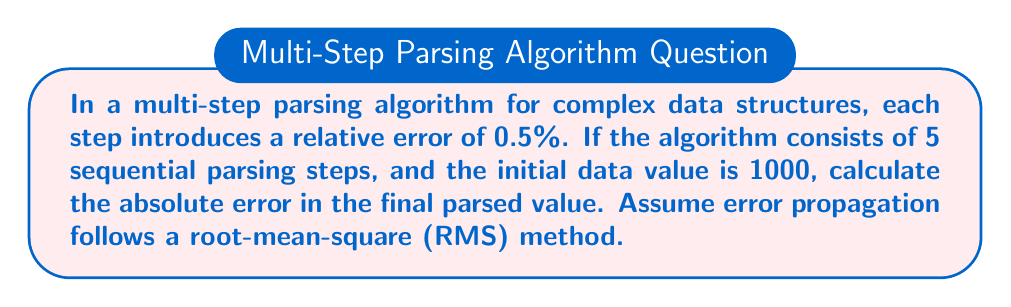Help me with this question. To solve this problem, we'll follow these steps:

1. Convert the relative error to decimal form:
   $$0.5\% = 0.005$$

2. Calculate the absolute error for each step:
   $$\text{Absolute Error per Step} = 1000 \times 0.005 = 5$$

3. Use the root-mean-square (RMS) method to calculate the total error:
   $$\text{Total Error} = \sqrt{\sum_{i=1}^{n} (\text{Error}_i)^2}$$
   Where n is the number of steps (5 in this case)

4. Substitute the values:
   $$\text{Total Error} = \sqrt{5^2 + 5^2 + 5^2 + 5^2 + 5^2}$$

5. Simplify:
   $$\text{Total Error} = \sqrt{5 \times 5^2} = \sqrt{125} = 5\sqrt{5}$$

6. Calculate the final value:
   $$\text{Final Value} = 5\sqrt{5} \approx 11.18$$

Therefore, the absolute error in the final parsed value is approximately 11.18.
Answer: $5\sqrt{5}$ 